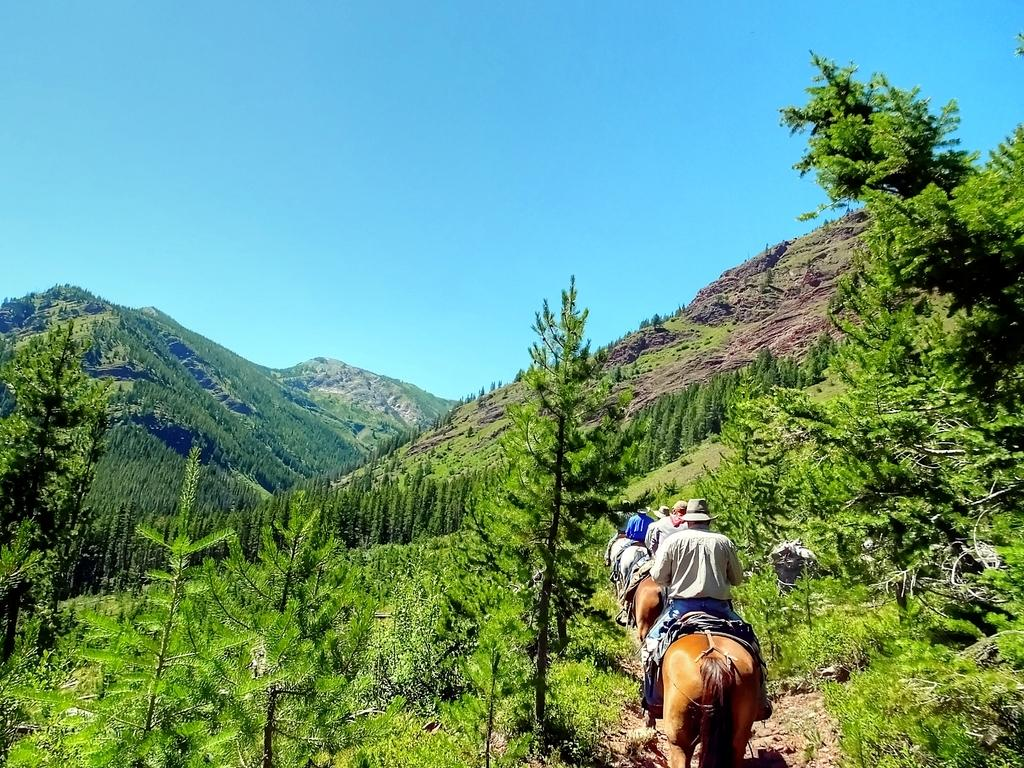How many people are in the image? There is a group of people in the image. What are the people doing in the image? The people are riding a horse. What are the people wearing on their heads? The people are wearing caps. What can be seen in the background of the image? There is a mountain, trees, and the sky visible in the background of the image. What type of property is being discussed by the people in the image? There is no indication in the image that the people are discussing any property. 